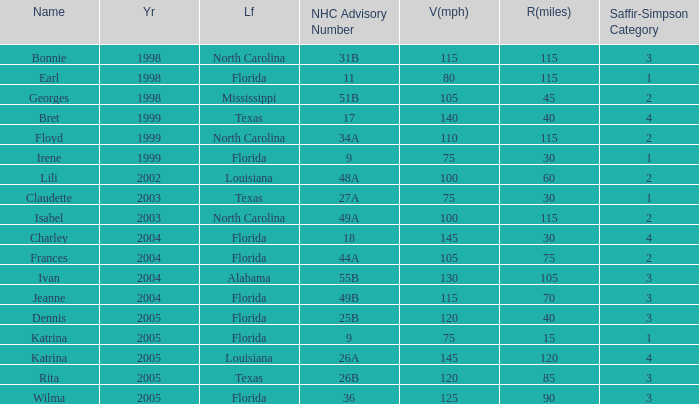Could you parse the entire table as a dict? {'header': ['Name', 'Yr', 'Lf', 'NHC Advisory Number', 'V(mph)', 'R(miles)', 'Saffir-Simpson Category'], 'rows': [['Bonnie', '1998', 'North Carolina', '31B', '115', '115', '3'], ['Earl', '1998', 'Florida', '11', '80', '115', '1'], ['Georges', '1998', 'Mississippi', '51B', '105', '45', '2'], ['Bret', '1999', 'Texas', '17', '140', '40', '4'], ['Floyd', '1999', 'North Carolina', '34A', '110', '115', '2'], ['Irene', '1999', 'Florida', '9', '75', '30', '1'], ['Lili', '2002', 'Louisiana', '48A', '100', '60', '2'], ['Claudette', '2003', 'Texas', '27A', '75', '30', '1'], ['Isabel', '2003', 'North Carolina', '49A', '100', '115', '2'], ['Charley', '2004', 'Florida', '18', '145', '30', '4'], ['Frances', '2004', 'Florida', '44A', '105', '75', '2'], ['Ivan', '2004', 'Alabama', '55B', '130', '105', '3'], ['Jeanne', '2004', 'Florida', '49B', '115', '70', '3'], ['Dennis', '2005', 'Florida', '25B', '120', '40', '3'], ['Katrina', '2005', 'Florida', '9', '75', '15', '1'], ['Katrina', '2005', 'Louisiana', '26A', '145', '120', '4'], ['Rita', '2005', 'Texas', '26B', '120', '85', '3'], ['Wilma', '2005', 'Florida', '36', '125', '90', '3']]} Which landfall was in category 1 for Saffir-Simpson in 1999? Florida. 